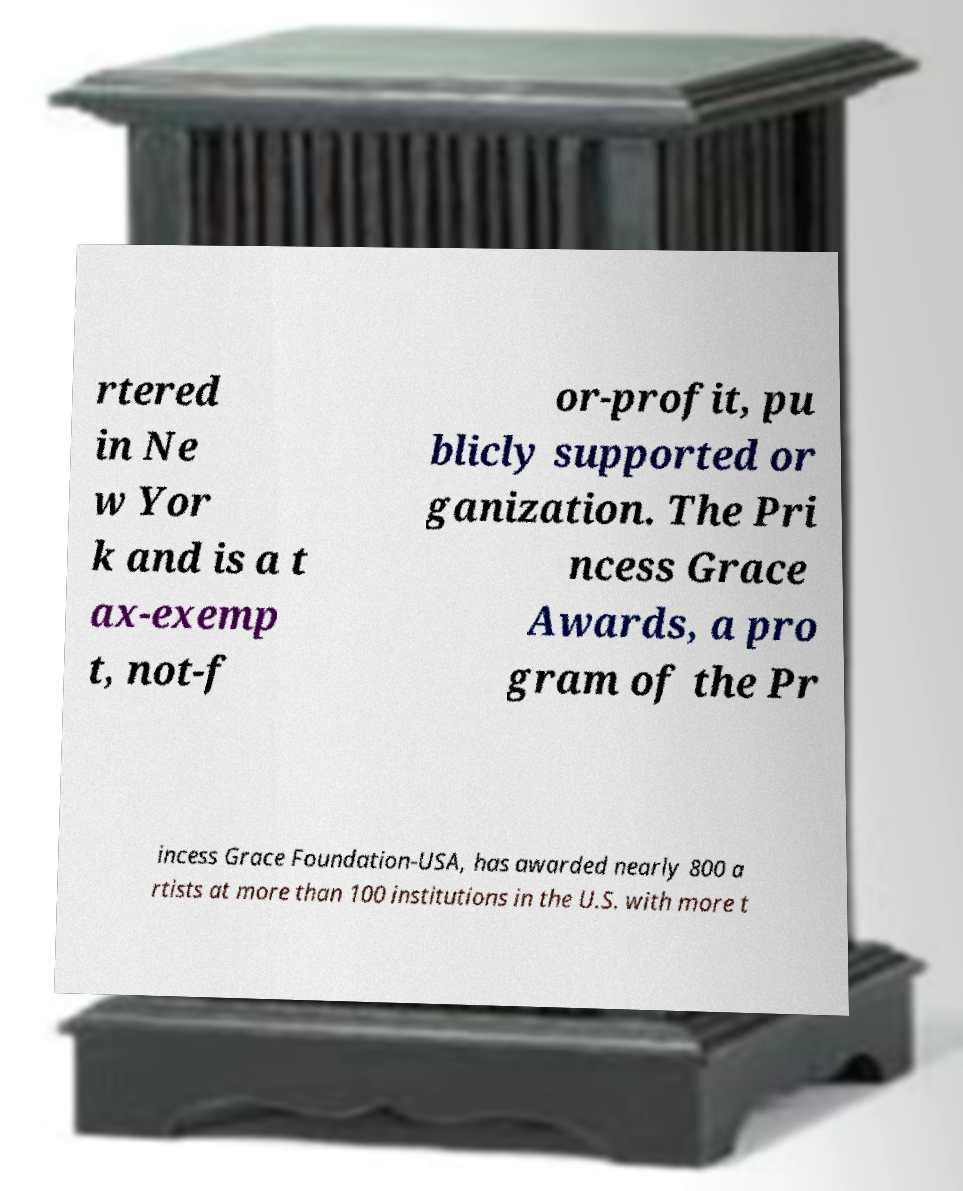Could you assist in decoding the text presented in this image and type it out clearly? rtered in Ne w Yor k and is a t ax-exemp t, not-f or-profit, pu blicly supported or ganization. The Pri ncess Grace Awards, a pro gram of the Pr incess Grace Foundation-USA, has awarded nearly 800 a rtists at more than 100 institutions in the U.S. with more t 